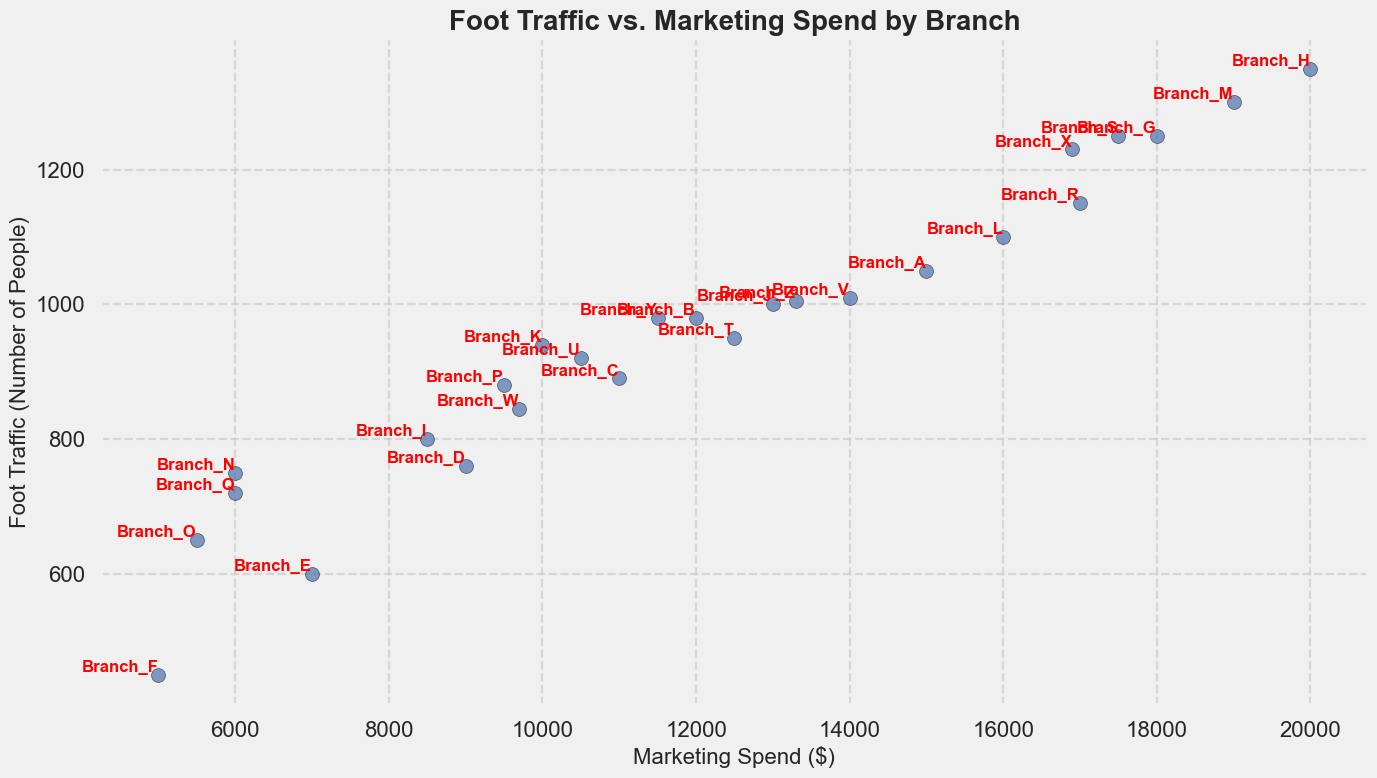Which branch has the highest foot traffic? Scan the plot for the point representing the highest foot traffic and look for the branch label next to it, which is Branch_H with 1350 foot traffic.
Answer: Branch_H Which branch has the lowest marketing spend? Locate the point with the lowest value on the x-axis (Marketing Spend) and read the corresponding branch label, which is Branch_F with $5000 spend.
Answer: Branch_F How many branches have a marketing spend greater than $15000? Count the number of points where the x-axis value (Marketing Spend) is greater than $15000. These branches are Branch_A, Branch_G, Branch_H, Branch_L, Branch_M, Branch_R, Branch_S, Branch_X.
Answer: 8 What is the combined foot traffic of Branch_A and Branch_G? Add the foot traffic values of Branch_A (1050) and Branch_G (1250), resulting in 1050 + 1250 = 2300.
Answer: 2300 Which branch has higher foot traffic, Branch_T or Branch_U? Refer to the plot and compare the foot traffic values of Branch_T (950) and Branch_U (920), where Branch_T has higher foot traffic.
Answer: Branch_T How much more is the marketing spend of Branch_H compared to Branch_A? Subtract the marketing spend of Branch_A ($15000) from that of Branch_H ($20000), resulting in $20000 - $15000 = $5000.
Answer: $5000 What is the average foot traffic for branches with marketing spend below $10000? Identify branches with marketing spend below $10000: Branch_D, Branch_E, Branch_F, Branch_I, Branch_N, Branch_O, Branch_P, Branch_Q. Calculate the average: (760 + 600 + 450 + 800 + 750 + 650 + 880 + 720) / 8 = 5610 / 8 = 701.25.
Answer: 701.25 Which branches have equal foot traffic to Branch_Z? Check the foot traffic value of Branch_Z (1005) and identify other branches, if any, with the same value. No other branches have a foot traffic value of 1005.
Answer: None How does the foot traffic of Branch_M compare to that of Branch_L? Compare the foot traffic values of Branch_M (1300) and Branch_L (1100). Branch_M has higher foot traffic than Branch_L.
Answer: Branch_M What is the marketing spend difference between the branch with the highest and lowest foot traffic? Identify the marketing spend for Branch_H ($20000, highest foot traffic) and Branch_F ($5000, lowest foot traffic). Calculate the difference: $20000 - $5000 = $15000.
Answer: $15000 